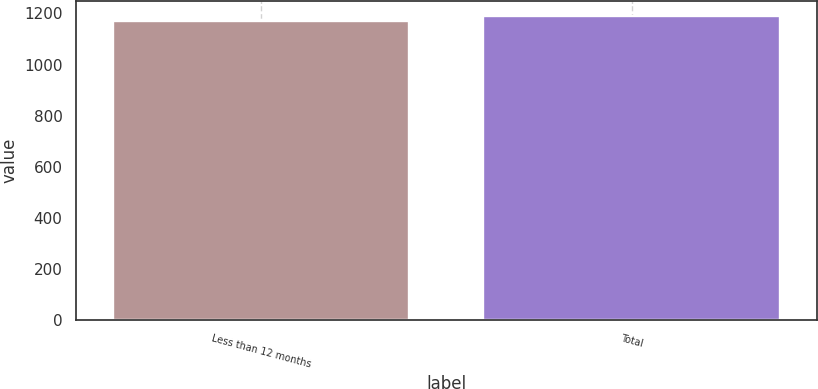<chart> <loc_0><loc_0><loc_500><loc_500><bar_chart><fcel>Less than 12 months<fcel>Total<nl><fcel>1169<fcel>1189<nl></chart> 